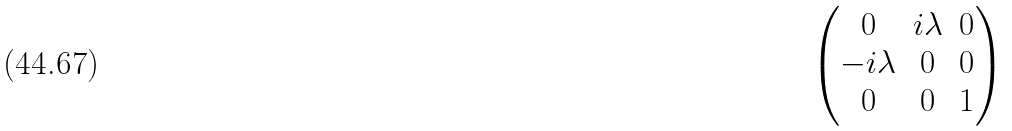Convert formula to latex. <formula><loc_0><loc_0><loc_500><loc_500>\begin{pmatrix} 0 & i \lambda & 0 \\ - i \lambda & 0 & 0 \\ 0 & 0 & 1 \end{pmatrix}</formula> 